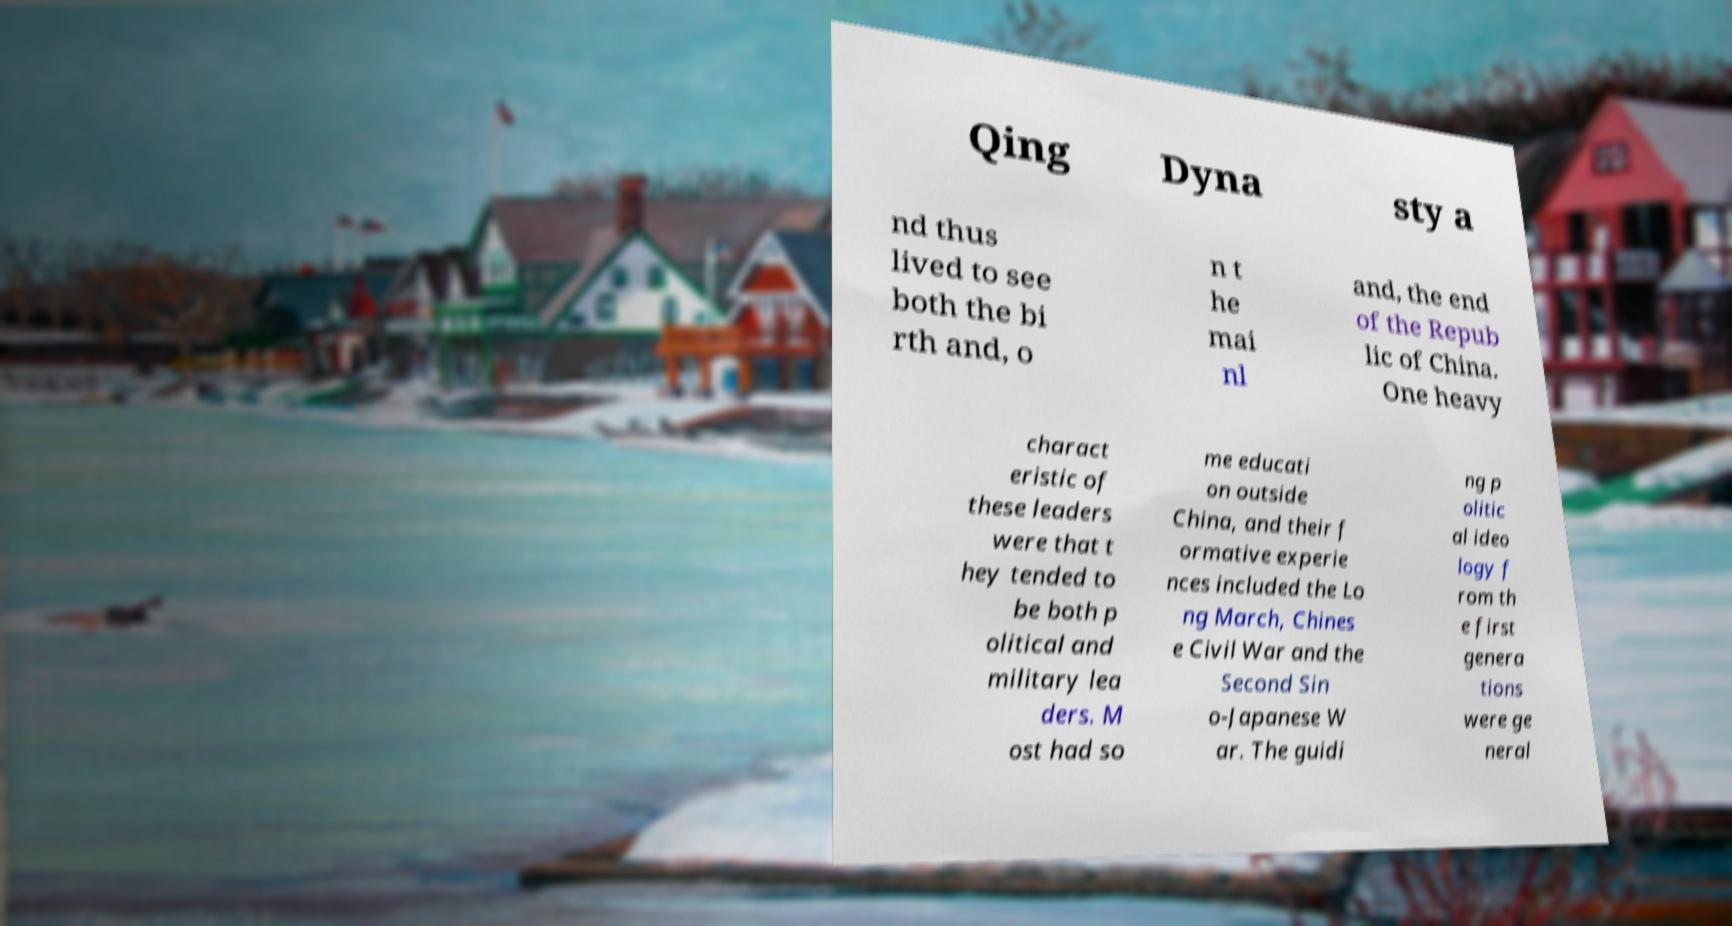Can you accurately transcribe the text from the provided image for me? Qing Dyna sty a nd thus lived to see both the bi rth and, o n t he mai nl and, the end of the Repub lic of China. One heavy charact eristic of these leaders were that t hey tended to be both p olitical and military lea ders. M ost had so me educati on outside China, and their f ormative experie nces included the Lo ng March, Chines e Civil War and the Second Sin o-Japanese W ar. The guidi ng p olitic al ideo logy f rom th e first genera tions were ge neral 